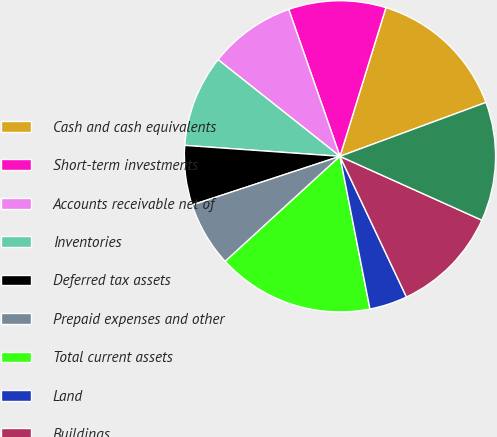Convert chart to OTSL. <chart><loc_0><loc_0><loc_500><loc_500><pie_chart><fcel>Cash and cash equivalents<fcel>Short-term investments<fcel>Accounts receivable net of<fcel>Inventories<fcel>Deferred tax assets<fcel>Prepaid expenses and other<fcel>Total current assets<fcel>Land<fcel>Buildings<fcel>Machinery and equipment<nl><fcel>14.6%<fcel>10.11%<fcel>8.99%<fcel>9.55%<fcel>6.18%<fcel>6.74%<fcel>16.29%<fcel>3.94%<fcel>11.24%<fcel>12.36%<nl></chart> 